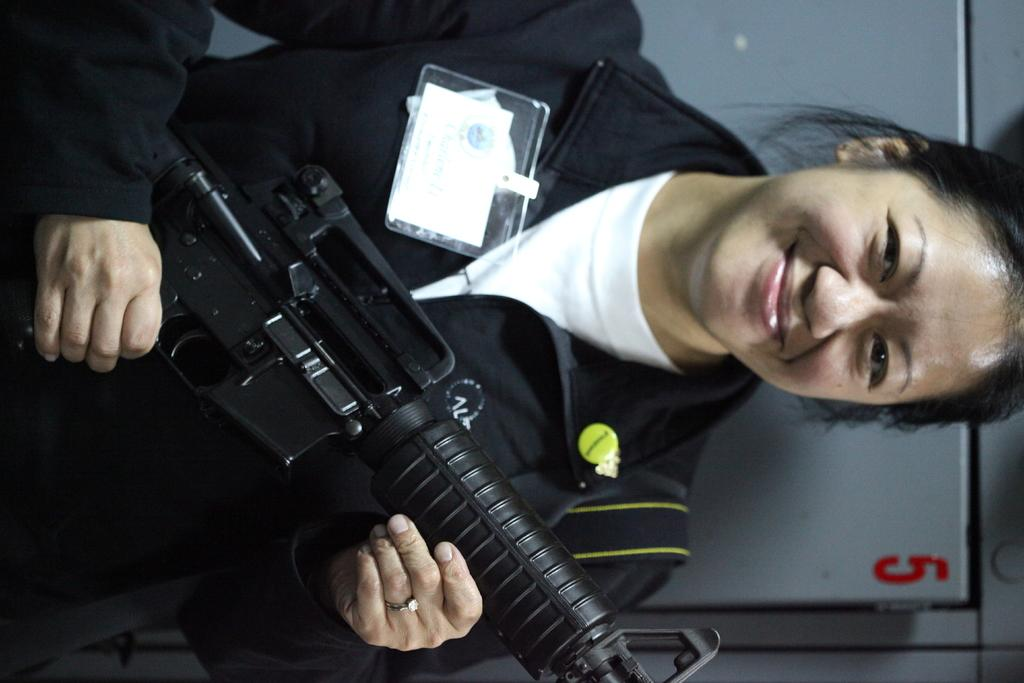Who is the main subject in the picture? There is a woman in the picture. What is the woman doing in the image? The woman is standing and smiling. What object is the woman holding in the picture? The woman is holding a gun. What type of ship can be seen in the background of the image? There is no ship present in the image; it only features a woman standing, smiling, and holding a gun. 